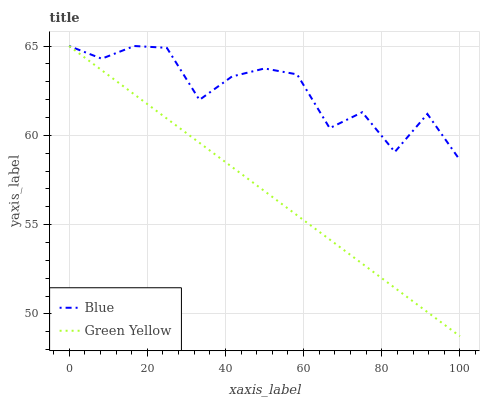Does Green Yellow have the maximum area under the curve?
Answer yes or no. No. Is Green Yellow the roughest?
Answer yes or no. No. 